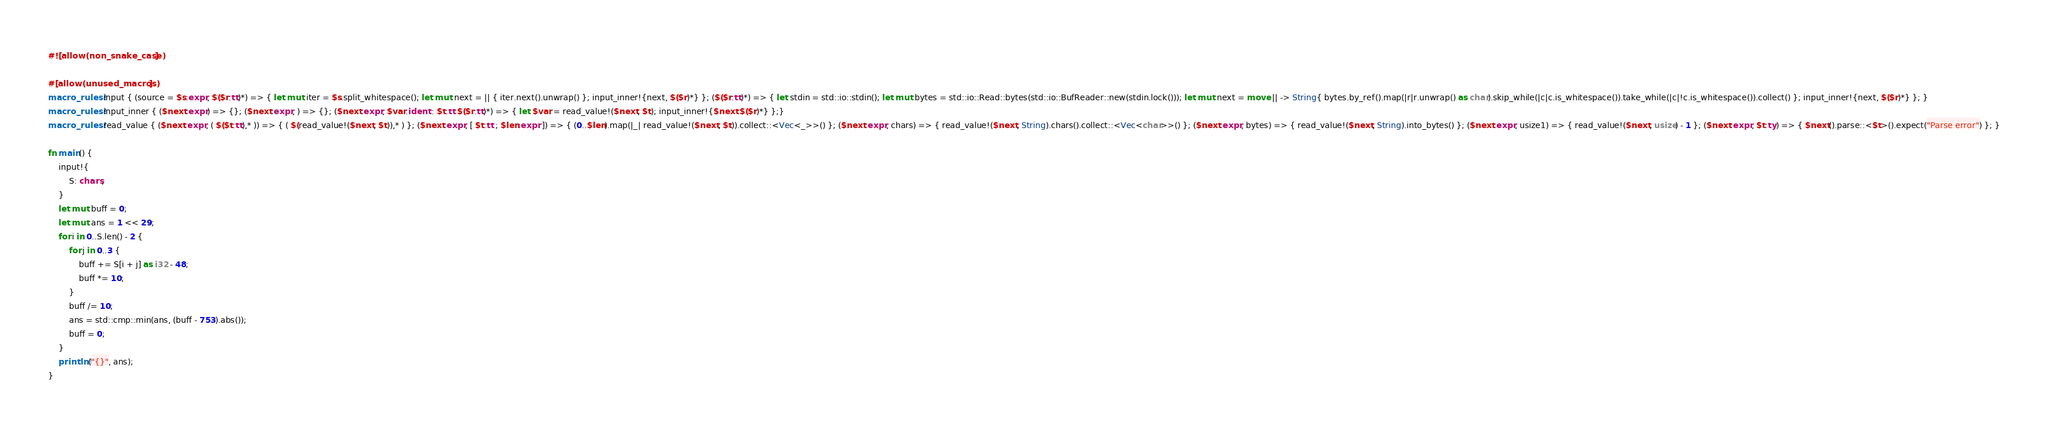Convert code to text. <code><loc_0><loc_0><loc_500><loc_500><_Rust_>#![allow(non_snake_case)]

#[allow(unused_macros)]
macro_rules! input { (source = $s:expr, $($r:tt)*) => { let mut iter = $s.split_whitespace(); let mut next = || { iter.next().unwrap() }; input_inner!{next, $($r)*} }; ($($r:tt)*) => { let stdin = std::io::stdin(); let mut bytes = std::io::Read::bytes(std::io::BufReader::new(stdin.lock())); let mut next = move || -> String{ bytes.by_ref().map(|r|r.unwrap() as char).skip_while(|c|c.is_whitespace()).take_while(|c|!c.is_whitespace()).collect() }; input_inner!{next, $($r)*} }; }
macro_rules! input_inner { ($next:expr) => {}; ($next:expr, ) => {}; ($next:expr, $var:ident : $t:tt $($r:tt)*) => { let $var = read_value!($next, $t); input_inner!{$next $($r)*} };}
macro_rules! read_value { ($next:expr, ( $($t:tt),* )) => { ( $(read_value!($next, $t)),* ) }; ($next:expr, [ $t:tt ; $len:expr ]) => { (0..$len).map(|_| read_value!($next, $t)).collect::<Vec<_>>() }; ($next:expr, chars) => { read_value!($next, String).chars().collect::<Vec<char>>() }; ($next:expr, bytes) => { read_value!($next, String).into_bytes() }; ($next:expr, usize1) => { read_value!($next, usize) - 1 }; ($next:expr, $t:ty) => { $next().parse::<$t>().expect("Parse error") }; }

fn main() {
    input!{
        S: chars,
    }
    let mut buff = 0;
    let mut ans = 1 << 29;
    for i in 0..S.len() - 2 {
        for j in 0..3 {
            buff += S[i + j] as i32 - 48;
            buff *= 10;
        }
        buff /= 10;
        ans = std::cmp::min(ans, (buff - 753).abs());
        buff = 0;
    }
    println!("{}", ans);
}</code> 